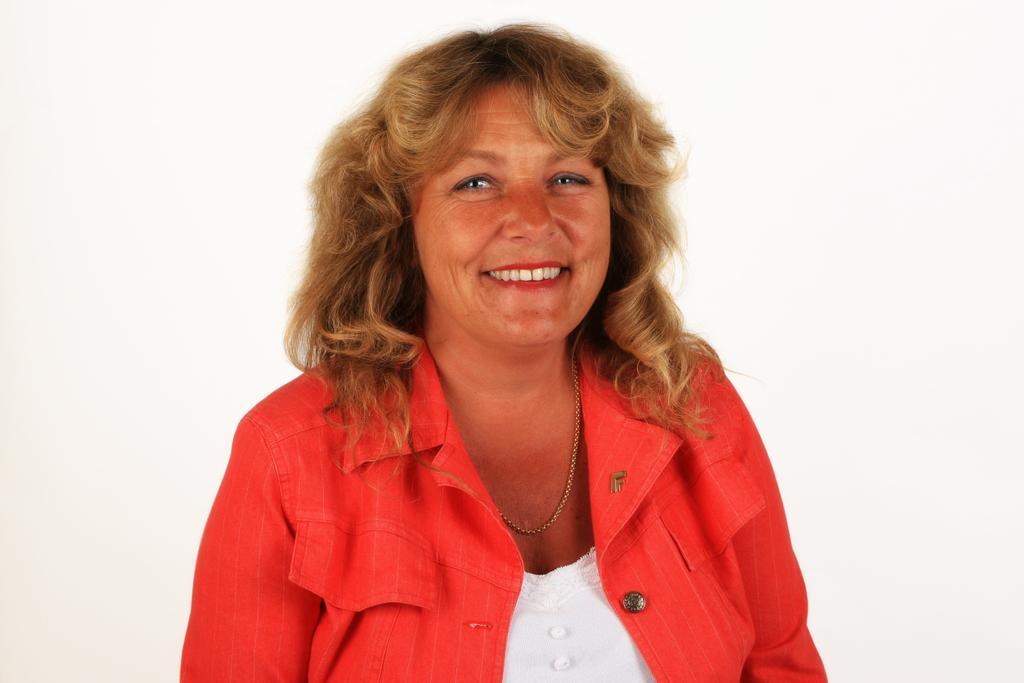Can you describe this image briefly? In this image I can see a woman is smiling. The woman is wearing a red color jacket. The background of the image is white in color. 